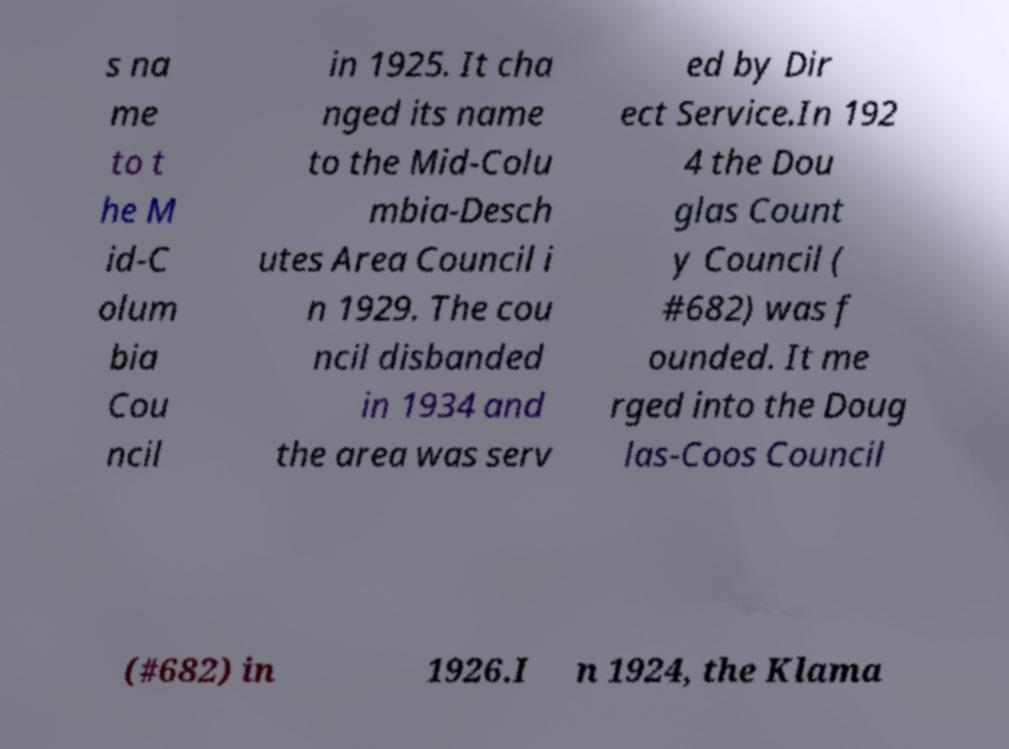What messages or text are displayed in this image? I need them in a readable, typed format. s na me to t he M id-C olum bia Cou ncil in 1925. It cha nged its name to the Mid-Colu mbia-Desch utes Area Council i n 1929. The cou ncil disbanded in 1934 and the area was serv ed by Dir ect Service.In 192 4 the Dou glas Count y Council ( #682) was f ounded. It me rged into the Doug las-Coos Council (#682) in 1926.I n 1924, the Klama 